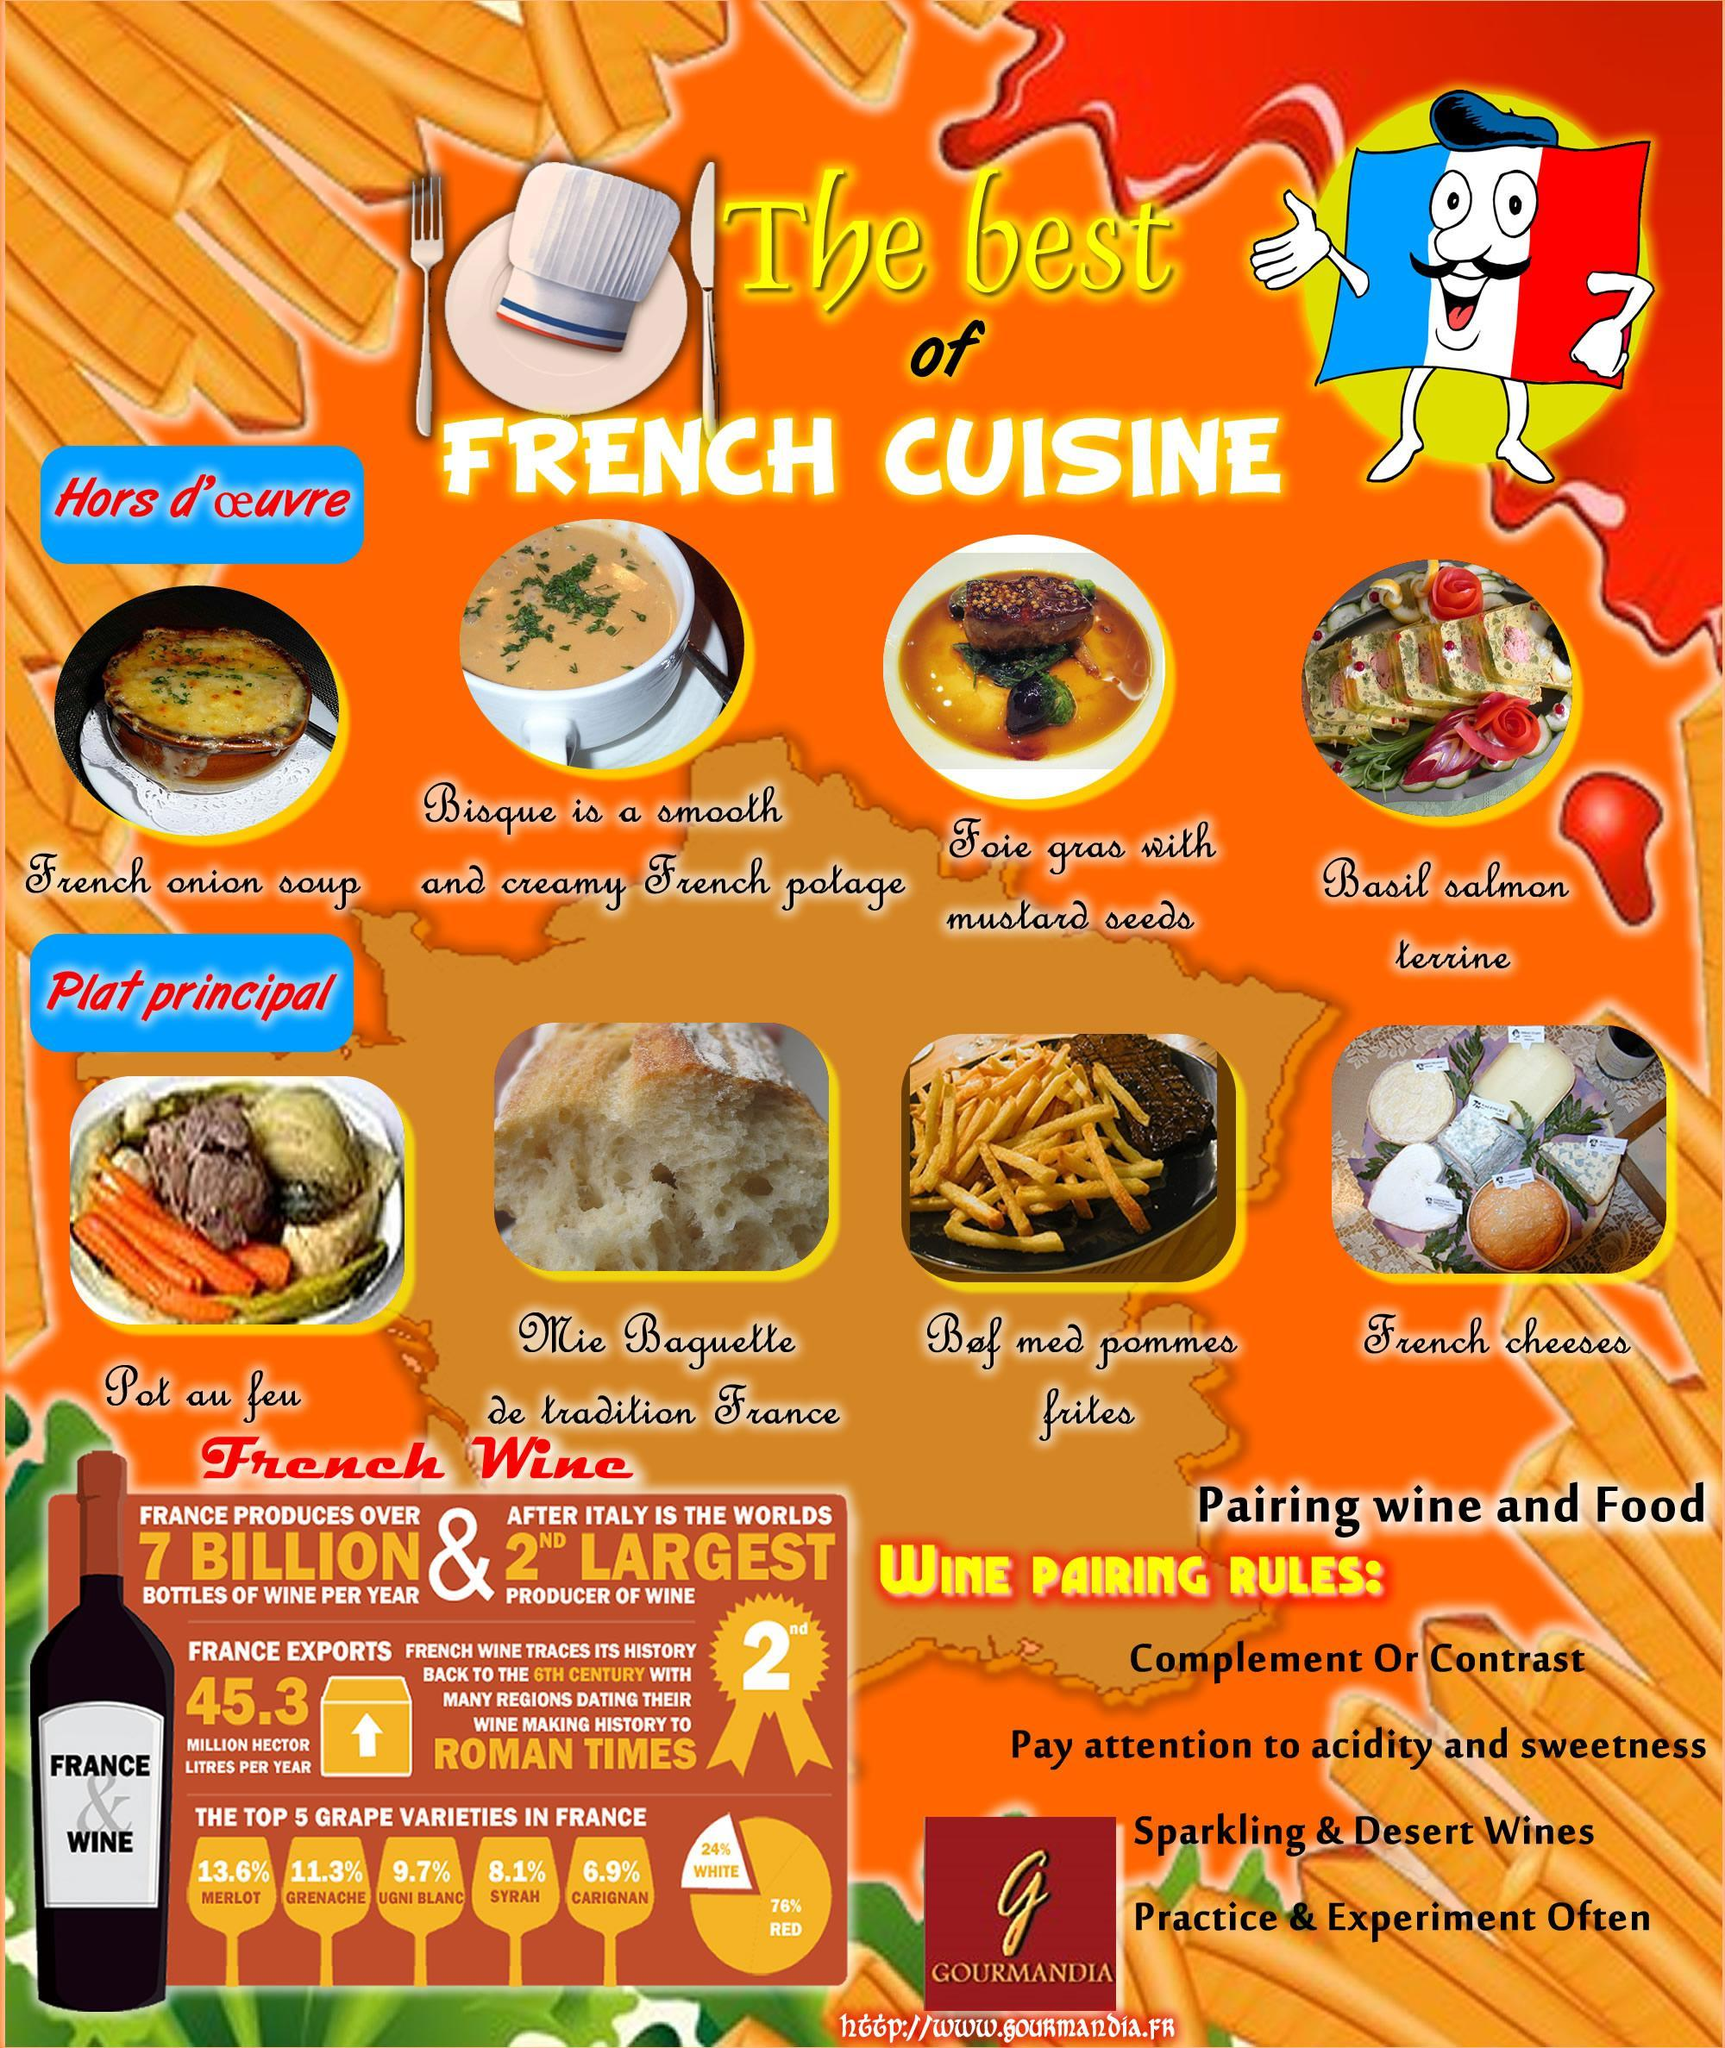Which is the largest producer of wine in the world?
Answer the question with a short phrase. Italy How many points are given under "Wine Pairing Rules"? 4 Which is the most popular grape variety in France? Merlot Which type of wine is produced more in France? Red What are the words written on the label of the bottle? France, Wine Food items in which culinary style are shown here? French How many food items are shown in the poster? 8 